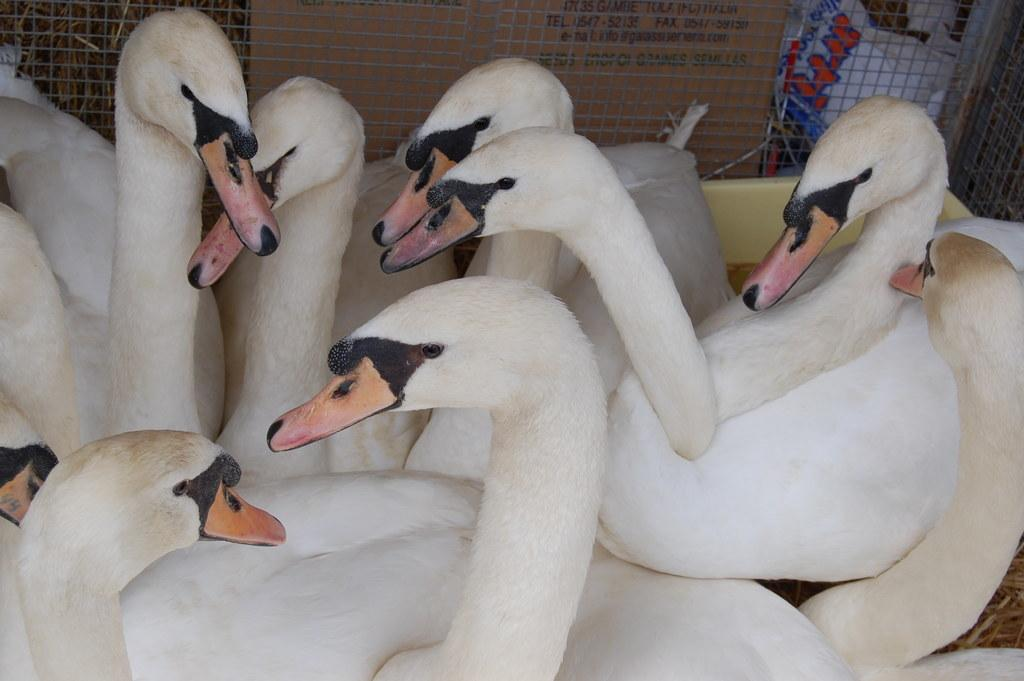What animals are in the front of the image? There are swans in the front of the image. What object can be seen in the background of the image? There is a cardboard box in the background of the image. What type of material is visible in the image? There is mesh visible in the image. What type of vegetable is being transported along the river in the image? There is no river or vegetable present in the image. What route are the swans taking in the image? The image does not show the swans taking a specific route; they are simply in the front of the image. 